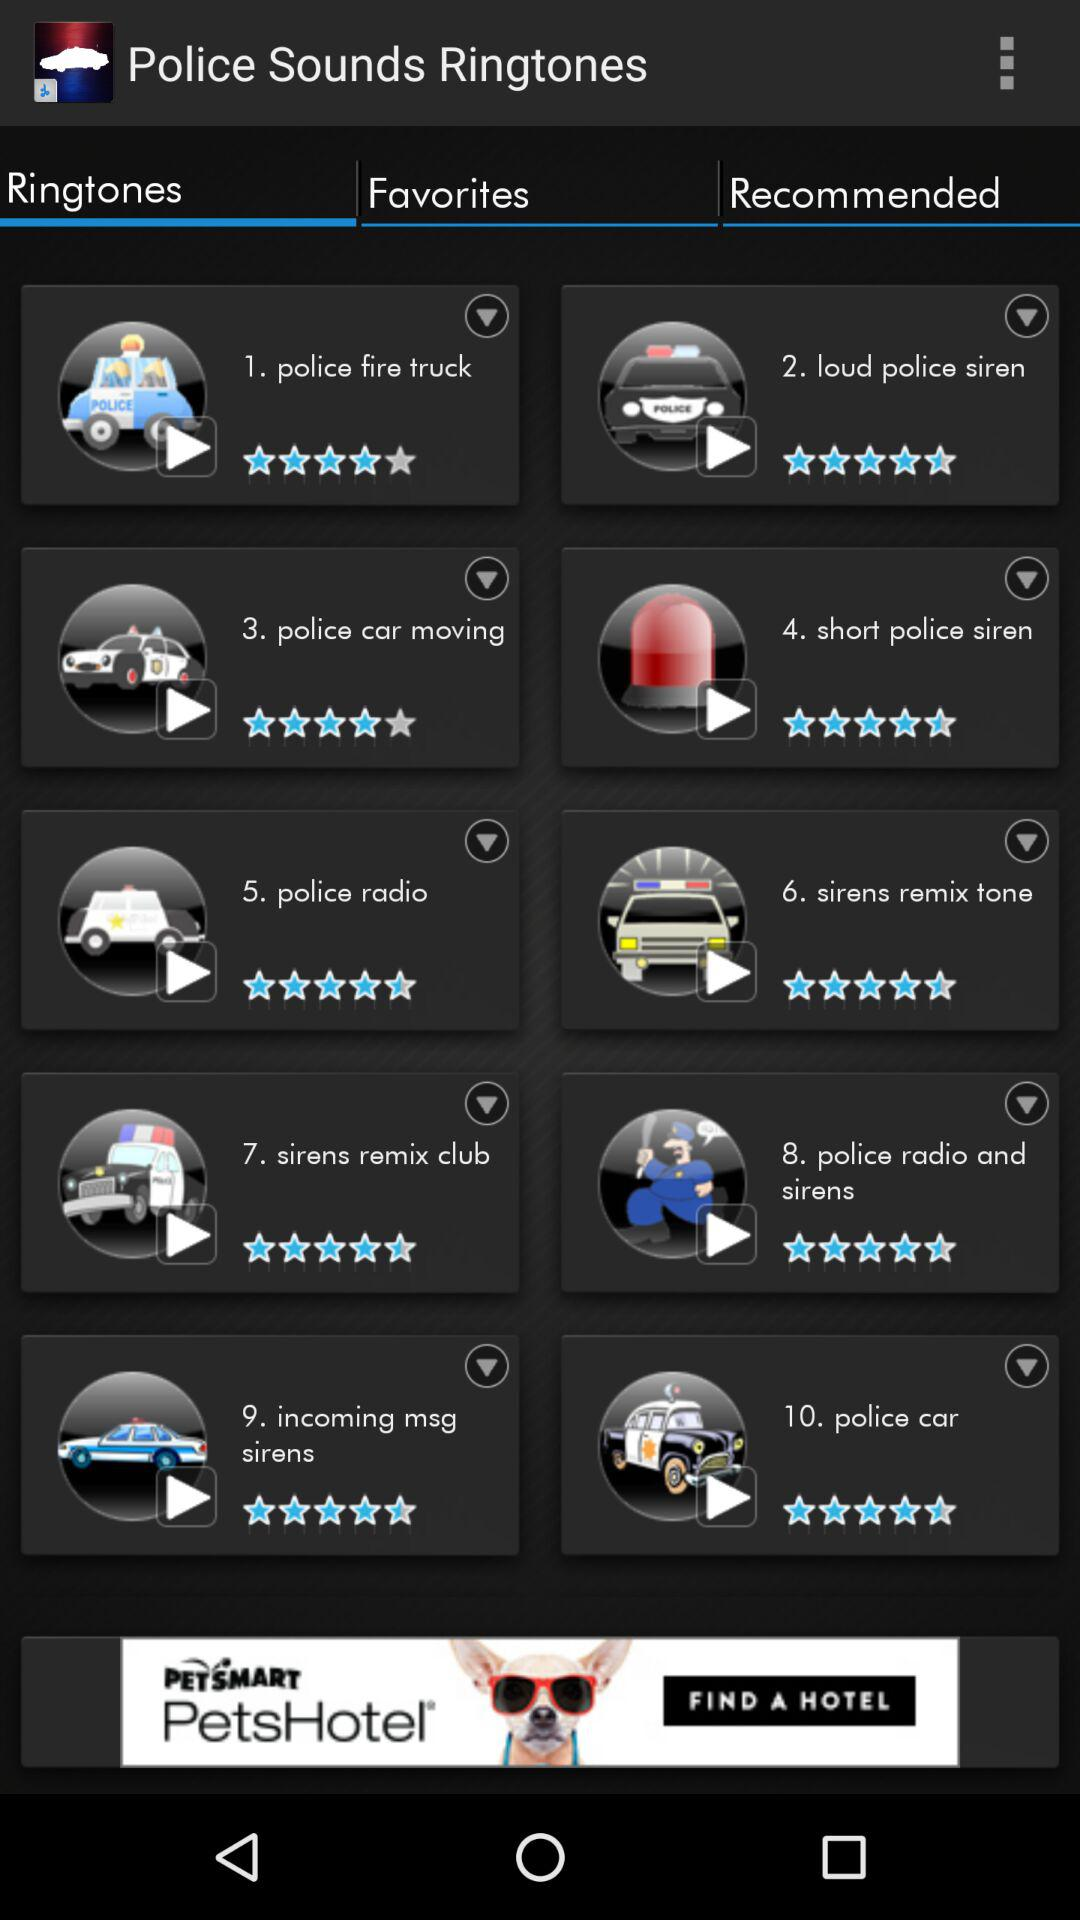Which tab is selected? The selected tab is "Ringtones". 